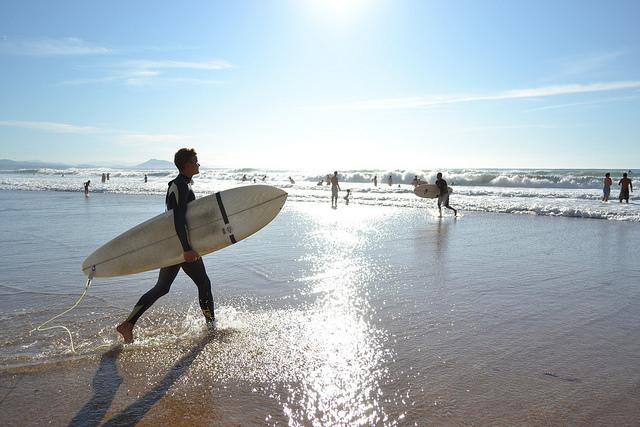Is the surfer in the foreground standing still?
Quick response, please. No. What is the man holding?
Short answer required. Surfboard. How many surfers are visible in the image?
Keep it brief. 2. 